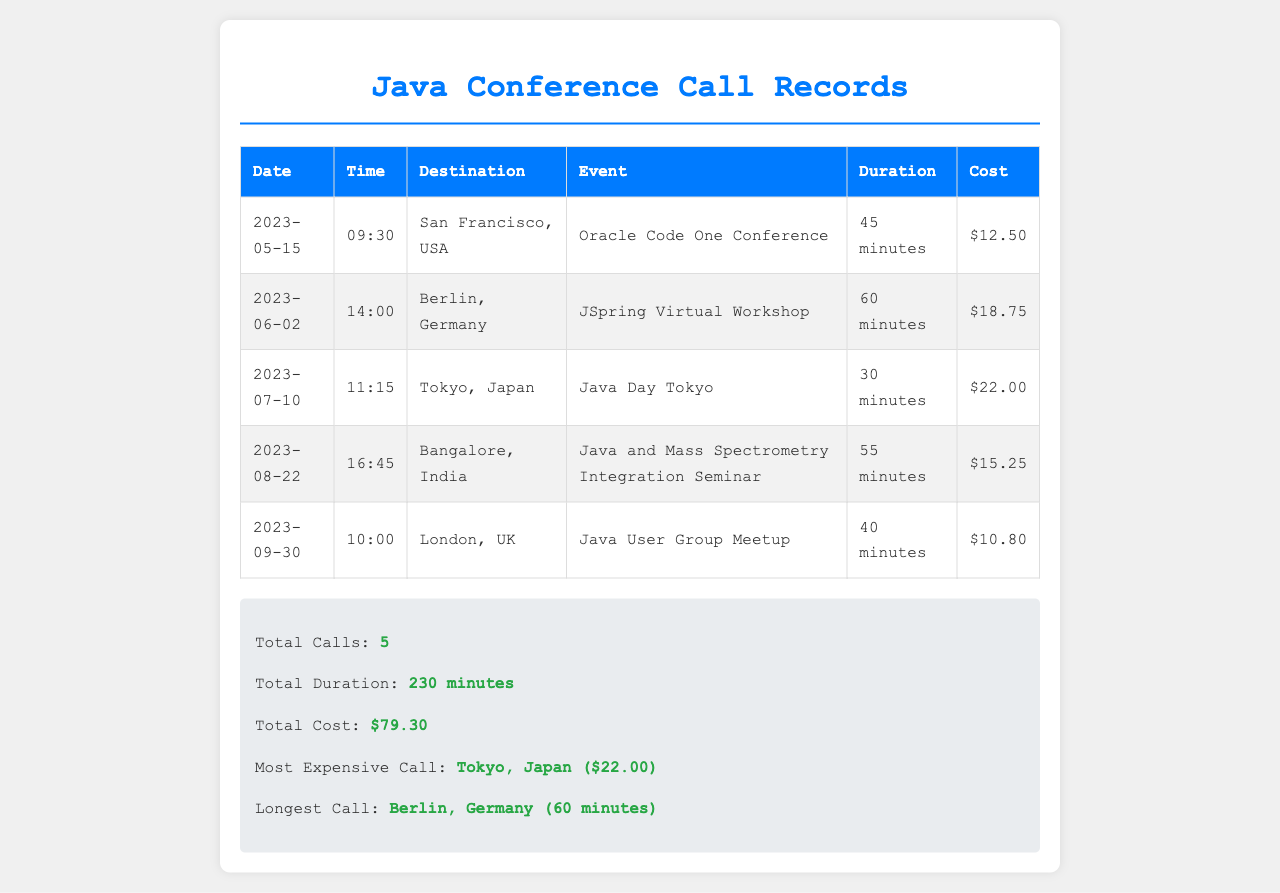What is the total cost of the calls? The total cost is presented in the summary section of the document, aggregating all call costs.
Answer: $79.30 Which call had the longest duration? The longest duration is highlighted in the summary, indicating the specific event with the maximum time.
Answer: Berlin, Germany (60 minutes) What was the cost of the call to Tokyo, Japan? The document lists the specific cost associated with the call to Tokyo in the respective row of the table.
Answer: $22.00 How many calls were made in total? The total number of calls can be found in the summary section, reflecting all recorded calls.
Answer: 5 What was the destination of the call on May 15, 2023? Each row in the table specifies the destination for each call made, identifying it by date.
Answer: San Francisco, USA What was the event associated with the call made on August 22, 2023? The event is listed next to the date and destination for the corresponding call in the table.
Answer: Java and Mass Spectrometry Integration Seminar Which country was the call made to on September 30, 2023? The destination column in the table specifies the country associated with each respective call.
Answer: UK What was the time of the call for the Oracle Code One Conference? The time is recorded in the same row as the event, allowing for easy retrieval.
Answer: 09:30 